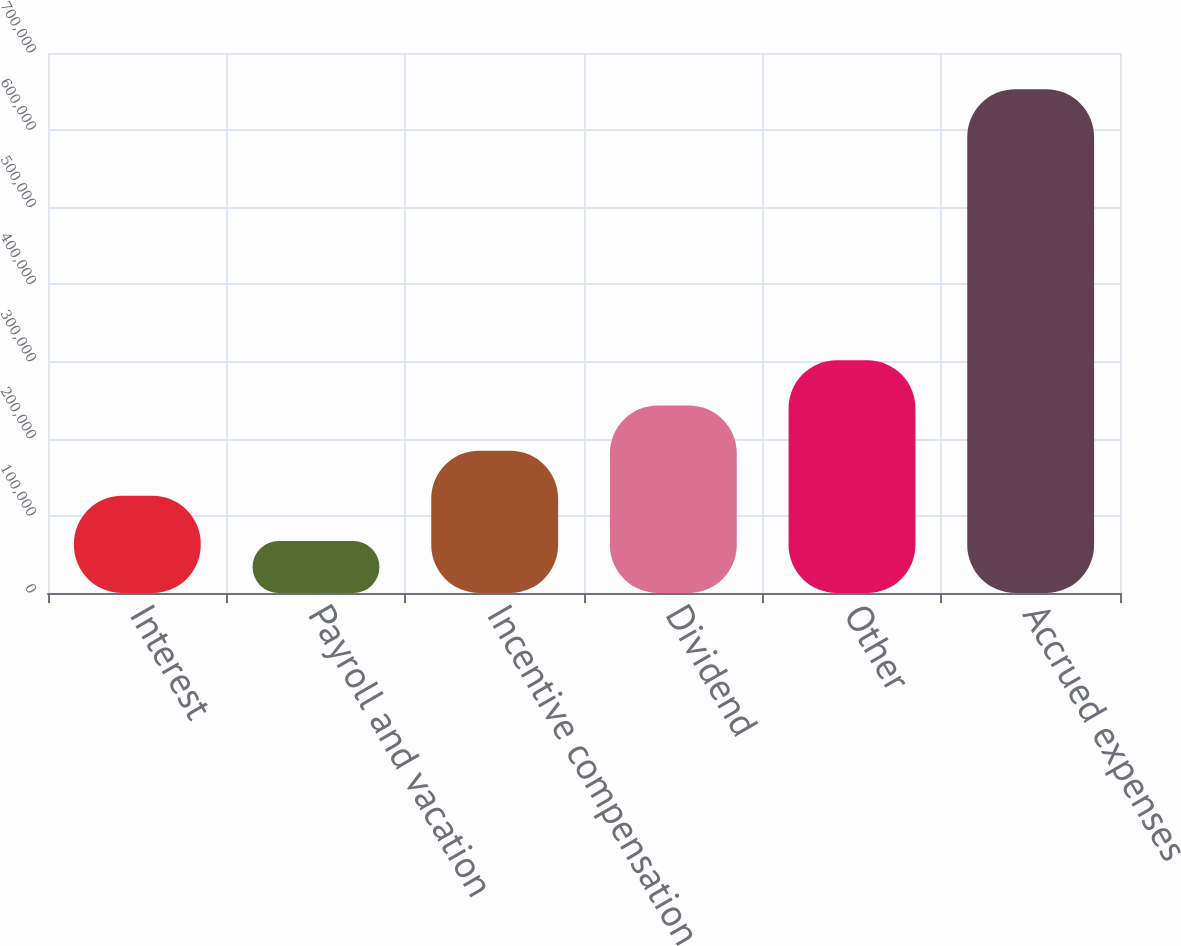Convert chart. <chart><loc_0><loc_0><loc_500><loc_500><bar_chart><fcel>Interest<fcel>Payroll and vacation<fcel>Incentive compensation<fcel>Dividend<fcel>Other<fcel>Accrued expenses<nl><fcel>125956<fcel>67379<fcel>184532<fcel>243109<fcel>301686<fcel>653146<nl></chart> 